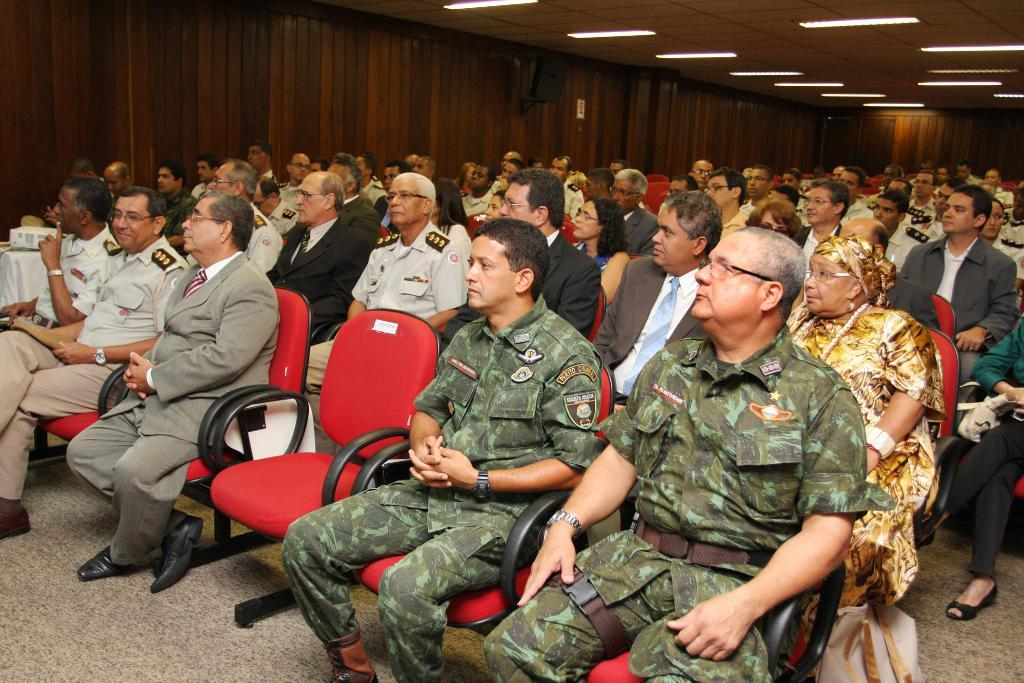How many people are in the image? There are many people in the image. What are the people doing in the image? The people are sitting on chairs. Can you describe the lighting in the image? There are many lights present on the roof. Can you tell me how many firemen are present in the image? There is no mention of firemen in the image, so it is not possible to determine their presence or number. 